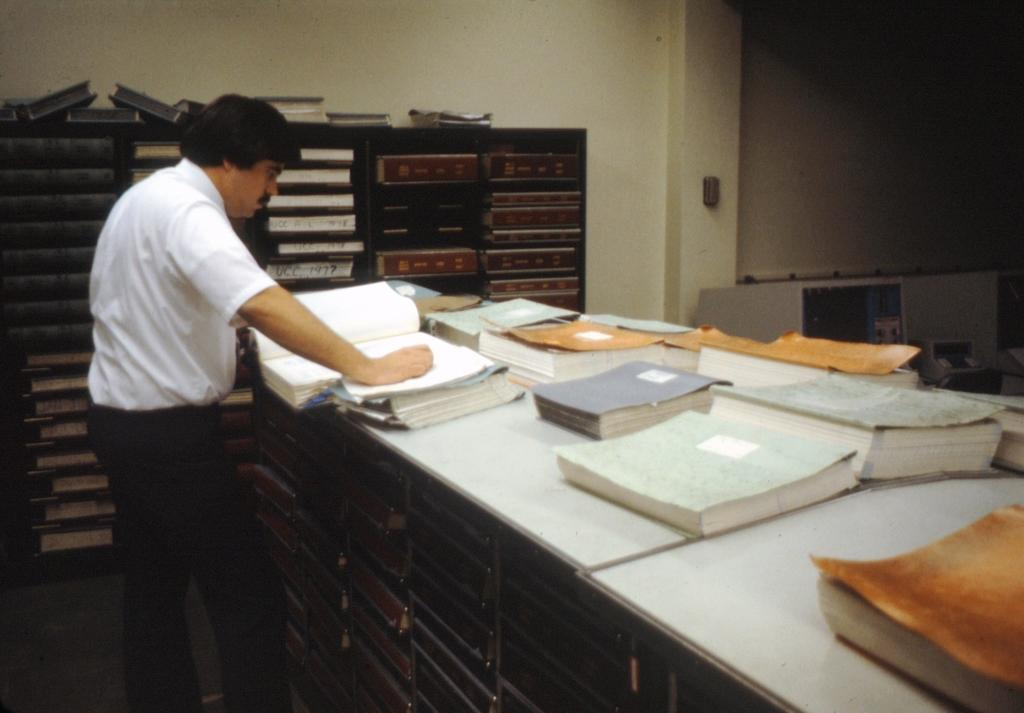What is the main subject in the image? There is a man standing in the image. What is the man standing near? There is a table with books in front of the man. What type of furniture can be seen in the image? There are racks in the image. What architectural features are present in the image? There is a wall and a pillar in the image. What type of sleet can be seen falling from the ceiling in the image? There is no sleet present in the image; it is an indoor setting with a man, table, books, racks, wall, and pillar. 